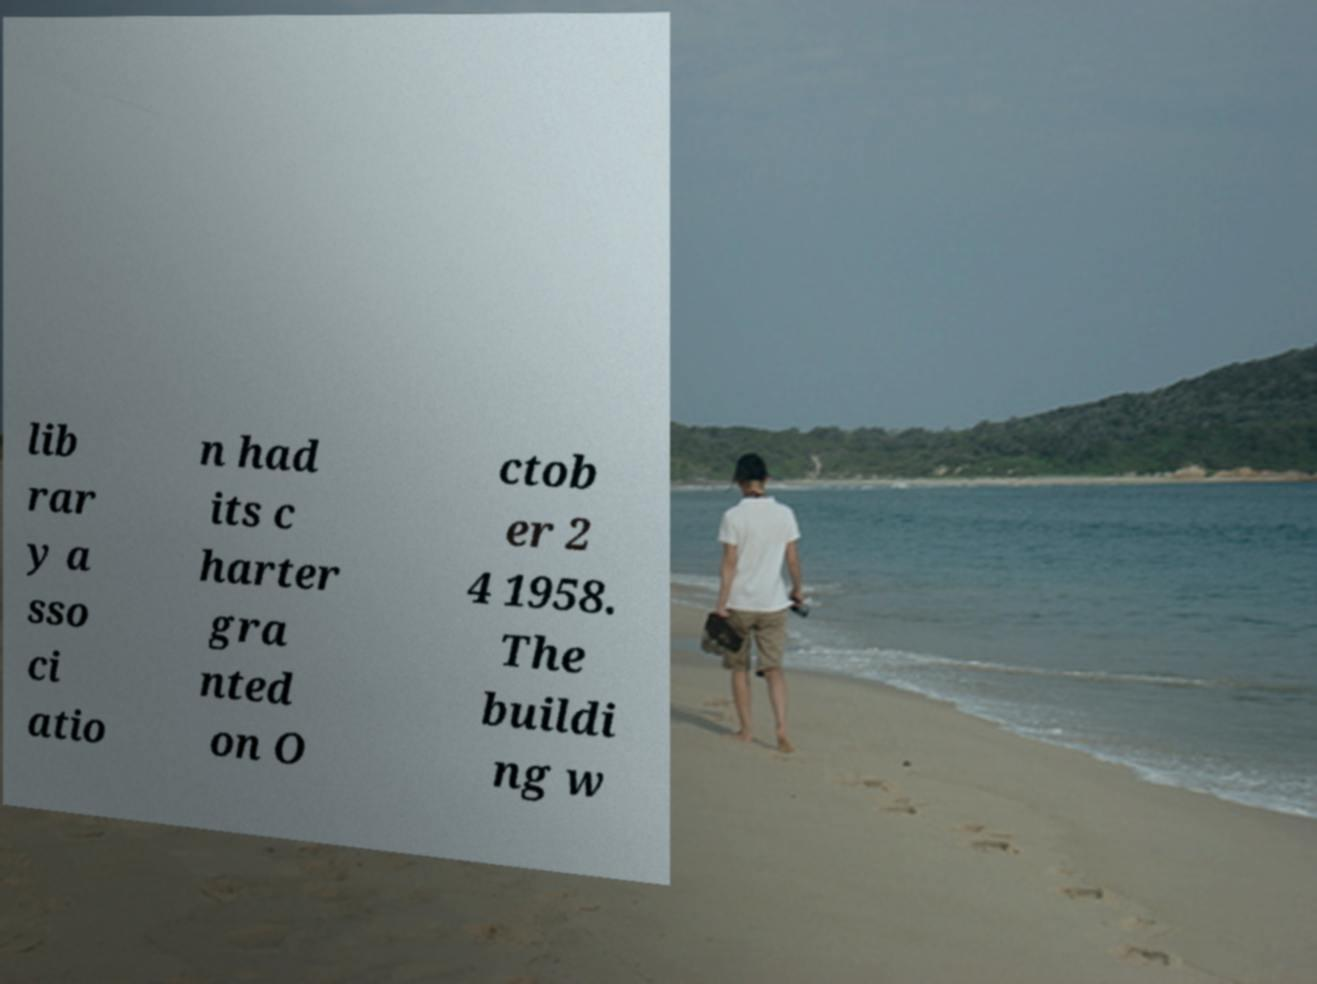Please identify and transcribe the text found in this image. lib rar y a sso ci atio n had its c harter gra nted on O ctob er 2 4 1958. The buildi ng w 